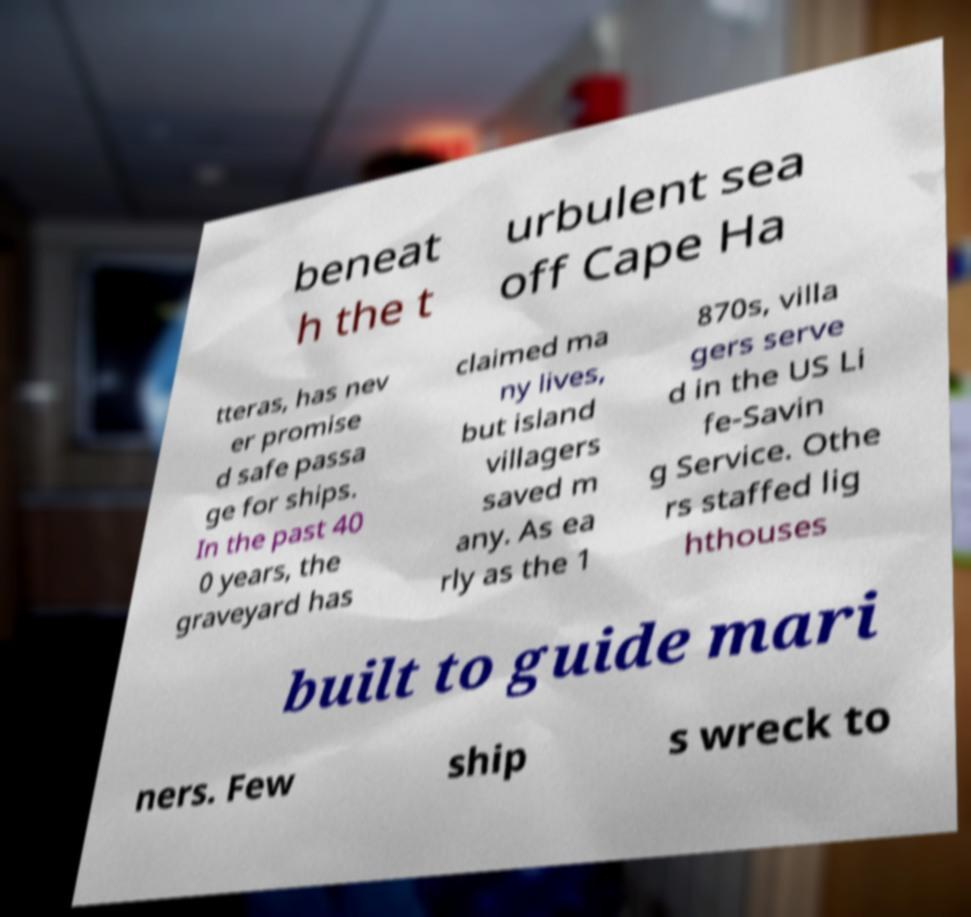Could you assist in decoding the text presented in this image and type it out clearly? beneat h the t urbulent sea off Cape Ha tteras, has nev er promise d safe passa ge for ships. In the past 40 0 years, the graveyard has claimed ma ny lives, but island villagers saved m any. As ea rly as the 1 870s, villa gers serve d in the US Li fe-Savin g Service. Othe rs staffed lig hthouses built to guide mari ners. Few ship s wreck to 